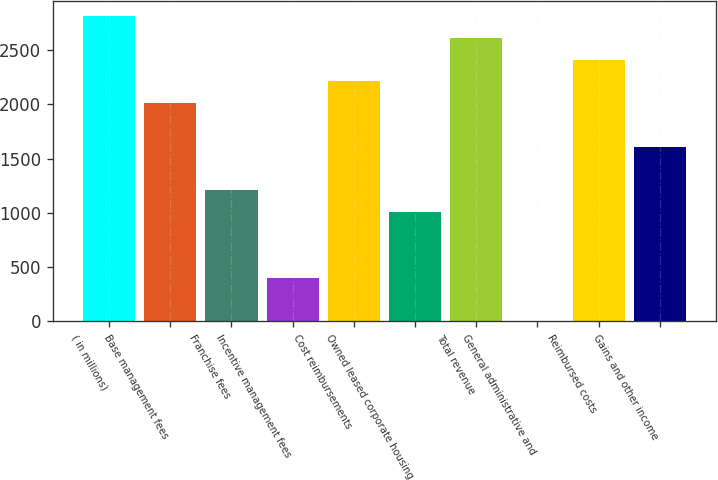Convert chart to OTSL. <chart><loc_0><loc_0><loc_500><loc_500><bar_chart><fcel>( in millions)<fcel>Base management fees<fcel>Franchise fees<fcel>Incentive management fees<fcel>Cost reimbursements<fcel>Owned leased corporate housing<fcel>Total revenue<fcel>General administrative and<fcel>Reimbursed costs<fcel>Gains and other income<nl><fcel>2813.6<fcel>2010<fcel>1206.4<fcel>402.8<fcel>2210.9<fcel>1005.5<fcel>2612.7<fcel>1<fcel>2411.8<fcel>1608.2<nl></chart> 